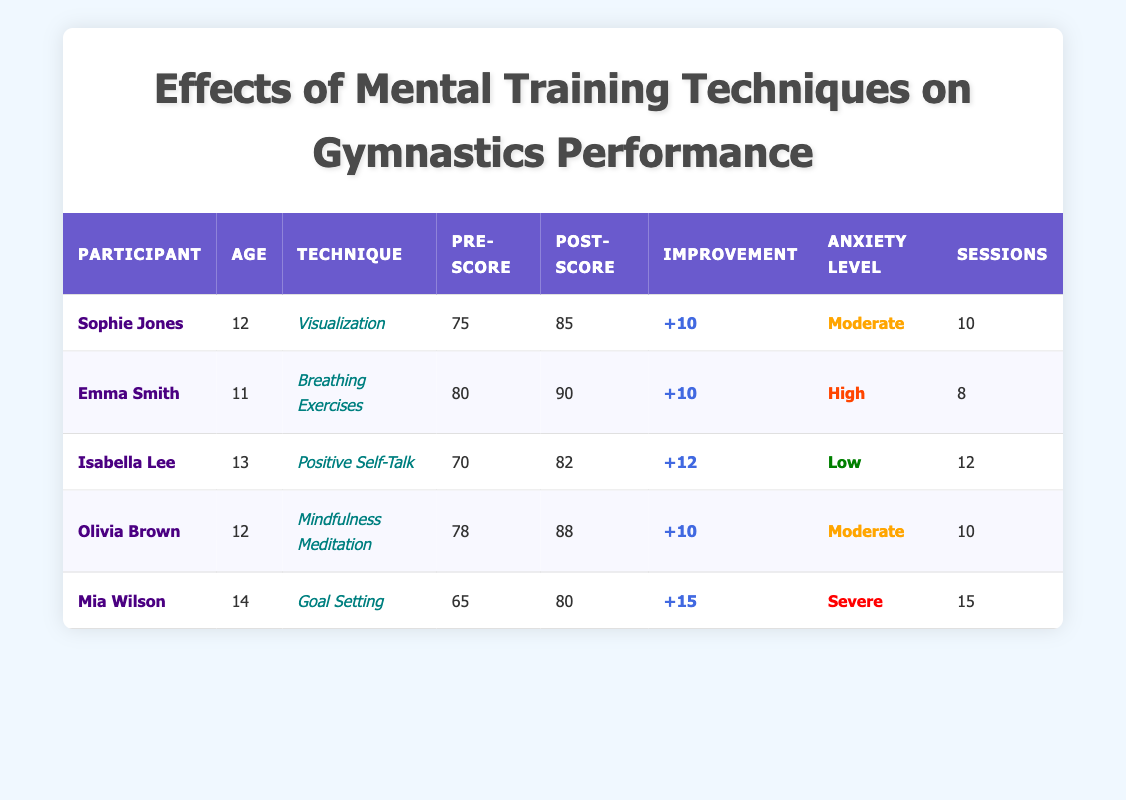What was Sophie Jones's Pre-Performance Score? By looking at the table, I can see that Sophie Jones has a Pre-Performance Score listed under her row, which is 75.
Answer: 75 How many sessions did Olivia Brown complete? The number of sessions for Olivia Brown can be found in the table next to her name, which indicates she completed 10 sessions.
Answer: 10 What was the average Post-Performance Score of all participants? To find the average Post-Performance Score, we first add up all the Post-Performance Scores: 85 (Sophie) + 90 (Emma) + 82 (Isabella) + 88 (Olivia) + 80 (Mia) = 425. There are 5 participants, so we divide 425 by 5, which equals 85.
Answer: 85 Which technique led to the highest improvement in performance? I need to look at the Improvement column and identify which score is the highest. The improvements are +10 (Sophie), +10 (Emma), +12 (Isabella), +10 (Olivia), and +15 (Mia). The highest is +15, which is associated with the Goal Setting technique of Mia Wilson.
Answer: Goal Setting Is Emma Smith older than Isabella Lee? I can compare the ages in the table; Emma Smith is 11 and Isabella Lee is 13. Since 11 is less than 13, Emma is not older than Isabella.
Answer: No What is the total number of sessions completed by participants with a high anxiety level? From the table, only Emma Smith has a high anxiety level, and she completed 8 sessions. Thus, the total number of sessions for high anxiety is just 8.
Answer: 8 Which participant saw a performance improvement of 12 points? To find the participant with a 12-point improvement, I check the Improvement column and see that Isabella Lee improved by +12 points.
Answer: Isabella Lee Does anyone in the study have a pre-score lower than 70? I can check the Pre-Performance Scores in the table: 75 (Sophie), 80 (Emma), 70 (Isabella), 78 (Olivia), and 65 (Mia). Since 65 is lower than 70, the answer is yes.
Answer: Yes How does the anxiety level correlate with the improvement seen in each participant? Firstly, I look at the Improvement scores and anxiety levels. The correlation shows: Moderate (10), High (10), Low (12), Moderate (10), and Severe (15). The results suggest that higher anxiety does not necessarily lead to lower improvements, as Mia (Severe) had the highest improvement. A deeper analysis could explore this pattern, but for now, it appears mixed.
Answer: Mixed correlation 